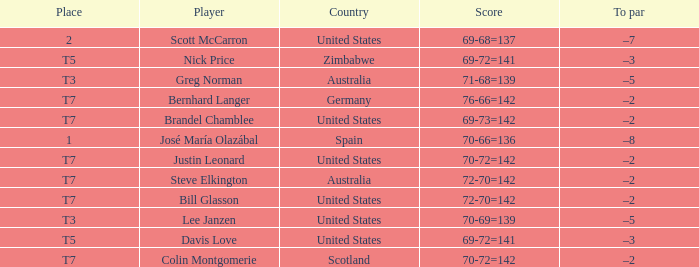Name the Player who has a To par of –2 and a Score of 69-73=142? Brandel Chamblee. 